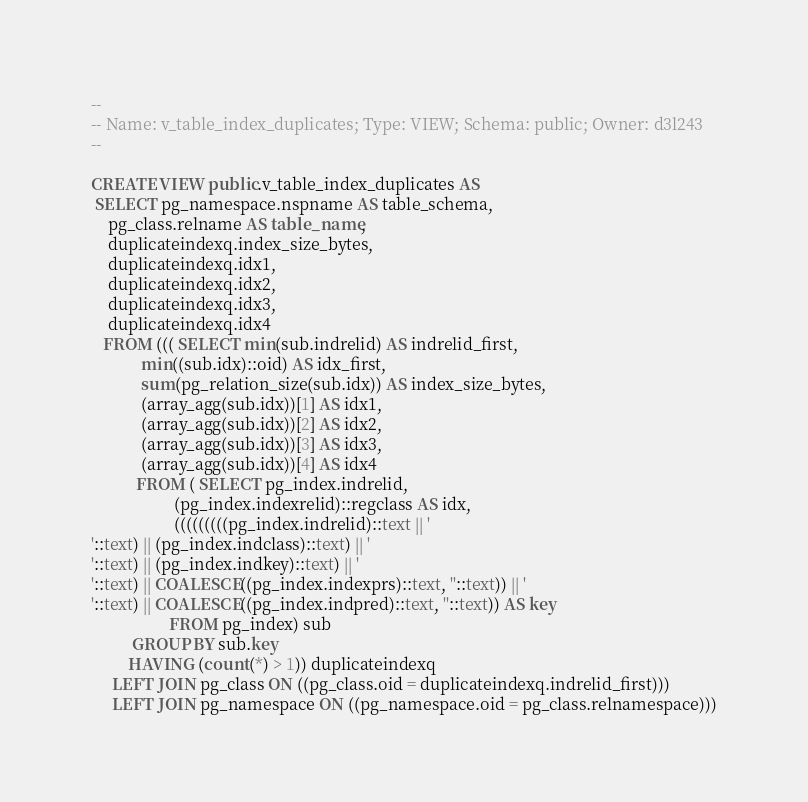Convert code to text. <code><loc_0><loc_0><loc_500><loc_500><_SQL_>--
-- Name: v_table_index_duplicates; Type: VIEW; Schema: public; Owner: d3l243
--

CREATE VIEW public.v_table_index_duplicates AS
 SELECT pg_namespace.nspname AS table_schema,
    pg_class.relname AS table_name,
    duplicateindexq.index_size_bytes,
    duplicateindexq.idx1,
    duplicateindexq.idx2,
    duplicateindexq.idx3,
    duplicateindexq.idx4
   FROM ((( SELECT min(sub.indrelid) AS indrelid_first,
            min((sub.idx)::oid) AS idx_first,
            sum(pg_relation_size(sub.idx)) AS index_size_bytes,
            (array_agg(sub.idx))[1] AS idx1,
            (array_agg(sub.idx))[2] AS idx2,
            (array_agg(sub.idx))[3] AS idx3,
            (array_agg(sub.idx))[4] AS idx4
           FROM ( SELECT pg_index.indrelid,
                    (pg_index.indexrelid)::regclass AS idx,
                    (((((((((pg_index.indrelid)::text || '
'::text) || (pg_index.indclass)::text) || '
'::text) || (pg_index.indkey)::text) || '
'::text) || COALESCE((pg_index.indexprs)::text, ''::text)) || '
'::text) || COALESCE((pg_index.indpred)::text, ''::text)) AS key
                   FROM pg_index) sub
          GROUP BY sub.key
         HAVING (count(*) > 1)) duplicateindexq
     LEFT JOIN pg_class ON ((pg_class.oid = duplicateindexq.indrelid_first)))
     LEFT JOIN pg_namespace ON ((pg_namespace.oid = pg_class.relnamespace)))</code> 